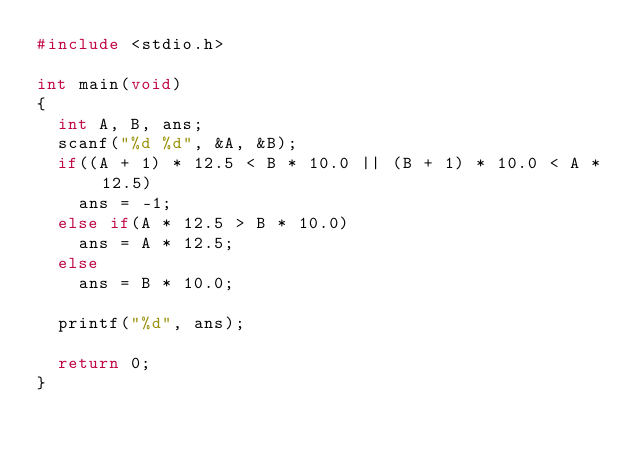Convert code to text. <code><loc_0><loc_0><loc_500><loc_500><_C_>#include <stdio.h>

int main(void)
{
  int A, B, ans;
  scanf("%d %d", &A, &B);
  if((A + 1) * 12.5 < B * 10.0 || (B + 1) * 10.0 < A * 12.5)
    ans = -1;
  else if(A * 12.5 > B * 10.0)
    ans = A * 12.5;
  else
    ans = B * 10.0;
  
  printf("%d", ans);
  
  return 0;
}

</code> 